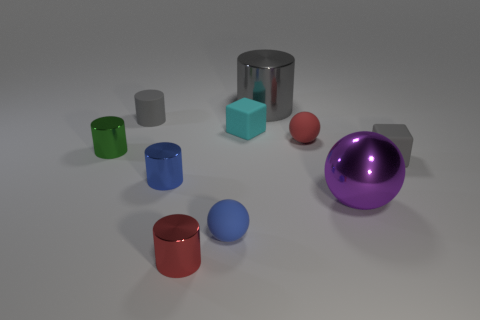Subtract all brown cylinders. Subtract all gray blocks. How many cylinders are left? 5 Subtract all blocks. How many objects are left? 8 Subtract 0 yellow spheres. How many objects are left? 10 Subtract all small matte cylinders. Subtract all tiny red cylinders. How many objects are left? 8 Add 3 green cylinders. How many green cylinders are left? 4 Add 10 large gray rubber blocks. How many large gray rubber blocks exist? 10 